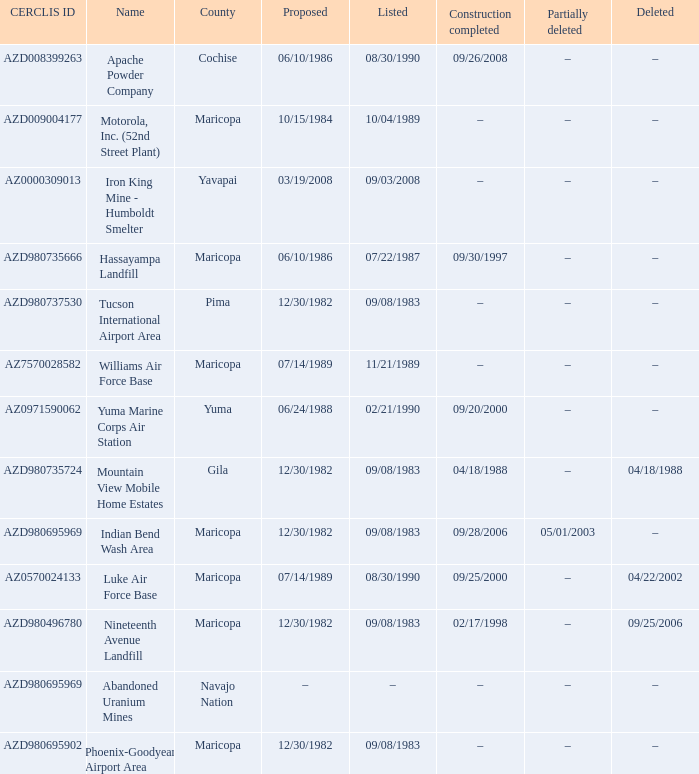When was the site partially deleted when the cerclis id is az7570028582? –. Can you parse all the data within this table? {'header': ['CERCLIS ID', 'Name', 'County', 'Proposed', 'Listed', 'Construction completed', 'Partially deleted', 'Deleted'], 'rows': [['AZD008399263', 'Apache Powder Company', 'Cochise', '06/10/1986', '08/30/1990', '09/26/2008', '–', '–'], ['AZD009004177', 'Motorola, Inc. (52nd Street Plant)', 'Maricopa', '10/15/1984', '10/04/1989', '–', '–', '–'], ['AZ0000309013', 'Iron King Mine - Humboldt Smelter', 'Yavapai', '03/19/2008', '09/03/2008', '–', '–', '–'], ['AZD980735666', 'Hassayampa Landfill', 'Maricopa', '06/10/1986', '07/22/1987', '09/30/1997', '–', '–'], ['AZD980737530', 'Tucson International Airport Area', 'Pima', '12/30/1982', '09/08/1983', '–', '–', '–'], ['AZ7570028582', 'Williams Air Force Base', 'Maricopa', '07/14/1989', '11/21/1989', '–', '–', '–'], ['AZ0971590062', 'Yuma Marine Corps Air Station', 'Yuma', '06/24/1988', '02/21/1990', '09/20/2000', '–', '–'], ['AZD980735724', 'Mountain View Mobile Home Estates', 'Gila', '12/30/1982', '09/08/1983', '04/18/1988', '–', '04/18/1988'], ['AZD980695969', 'Indian Bend Wash Area', 'Maricopa', '12/30/1982', '09/08/1983', '09/28/2006', '05/01/2003', '–'], ['AZ0570024133', 'Luke Air Force Base', 'Maricopa', '07/14/1989', '08/30/1990', '09/25/2000', '–', '04/22/2002'], ['AZD980496780', 'Nineteenth Avenue Landfill', 'Maricopa', '12/30/1982', '09/08/1983', '02/17/1998', '–', '09/25/2006'], ['AZD980695969', 'Abandoned Uranium Mines', 'Navajo Nation', '–', '–', '–', '–', '–'], ['AZD980695902', 'Phoenix-Goodyear Airport Area', 'Maricopa', '12/30/1982', '09/08/1983', '–', '–', '–']]} 